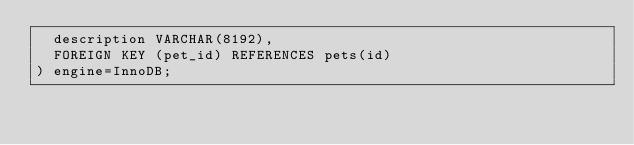Convert code to text. <code><loc_0><loc_0><loc_500><loc_500><_SQL_>  description VARCHAR(8192),
  FOREIGN KEY (pet_id) REFERENCES pets(id)
) engine=InnoDB;
</code> 